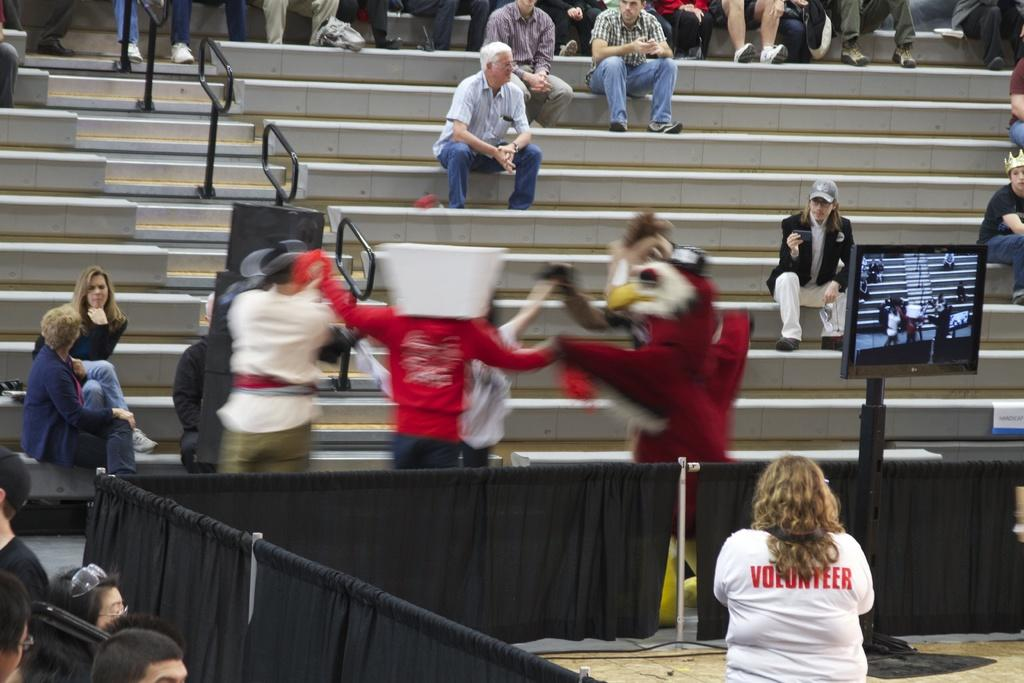How many people are in the image? There is a group of people in the image, but the exact number is not specified. What are some of the people in the image doing? Some people are sitting on steps, while others are standing. What can be seen in the background of the image? There are curtains present in the image. What type of electronic device is visible in the image? There is a television in the image. What is used for amplifying sound in the image? There are speakers in the image. What type of protective eyewear is present in the image? There are goggles in the image. What other objects can be seen in the image? There are other objects in the image, but their specific nature is not mentioned. Where is the faucet located in the image? There is no faucet present in the image. What type of salt is being used by the people in the image? There is no salt visible or mentioned in the image. 